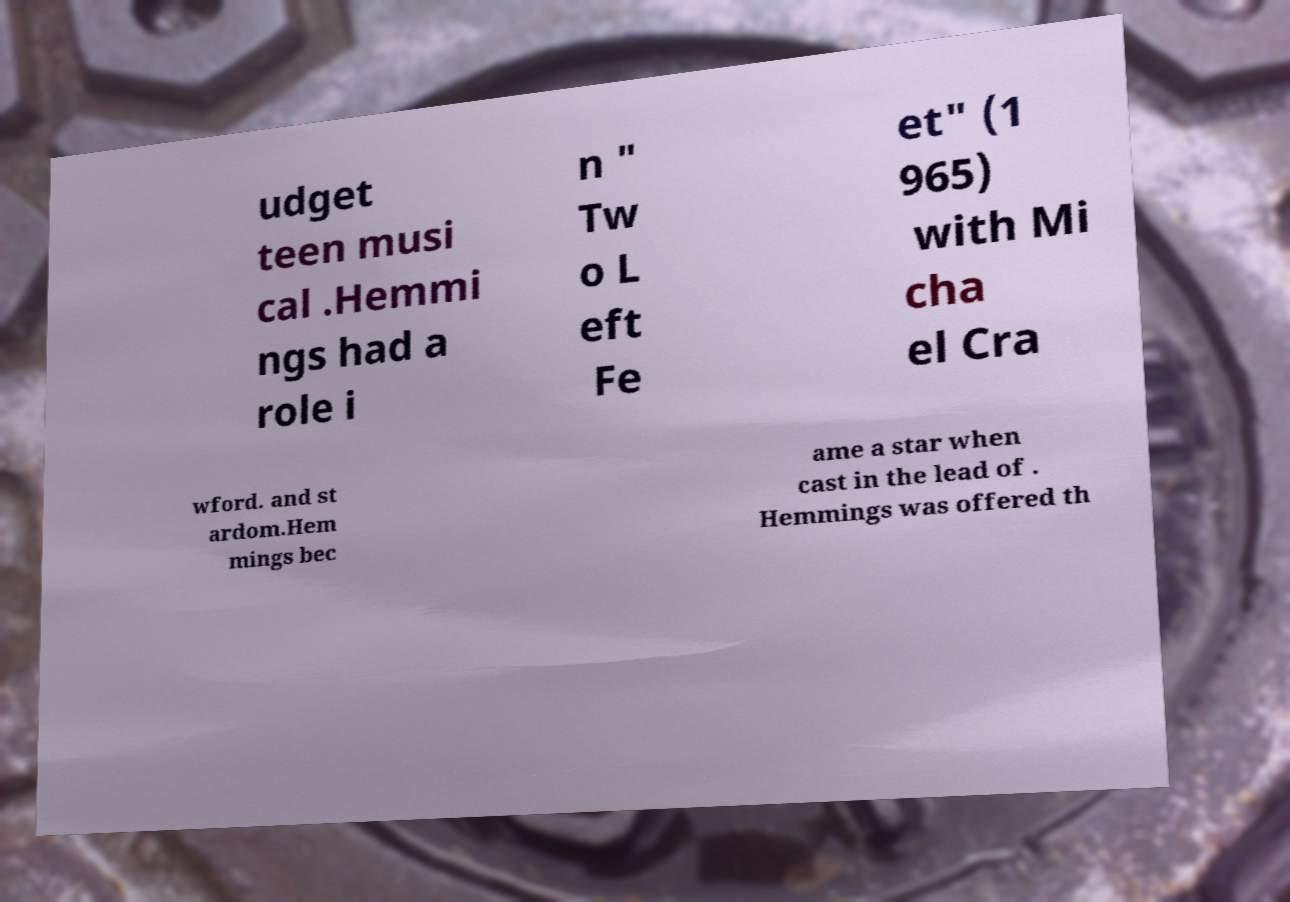For documentation purposes, I need the text within this image transcribed. Could you provide that? udget teen musi cal .Hemmi ngs had a role i n " Tw o L eft Fe et" (1 965) with Mi cha el Cra wford. and st ardom.Hem mings bec ame a star when cast in the lead of . Hemmings was offered th 